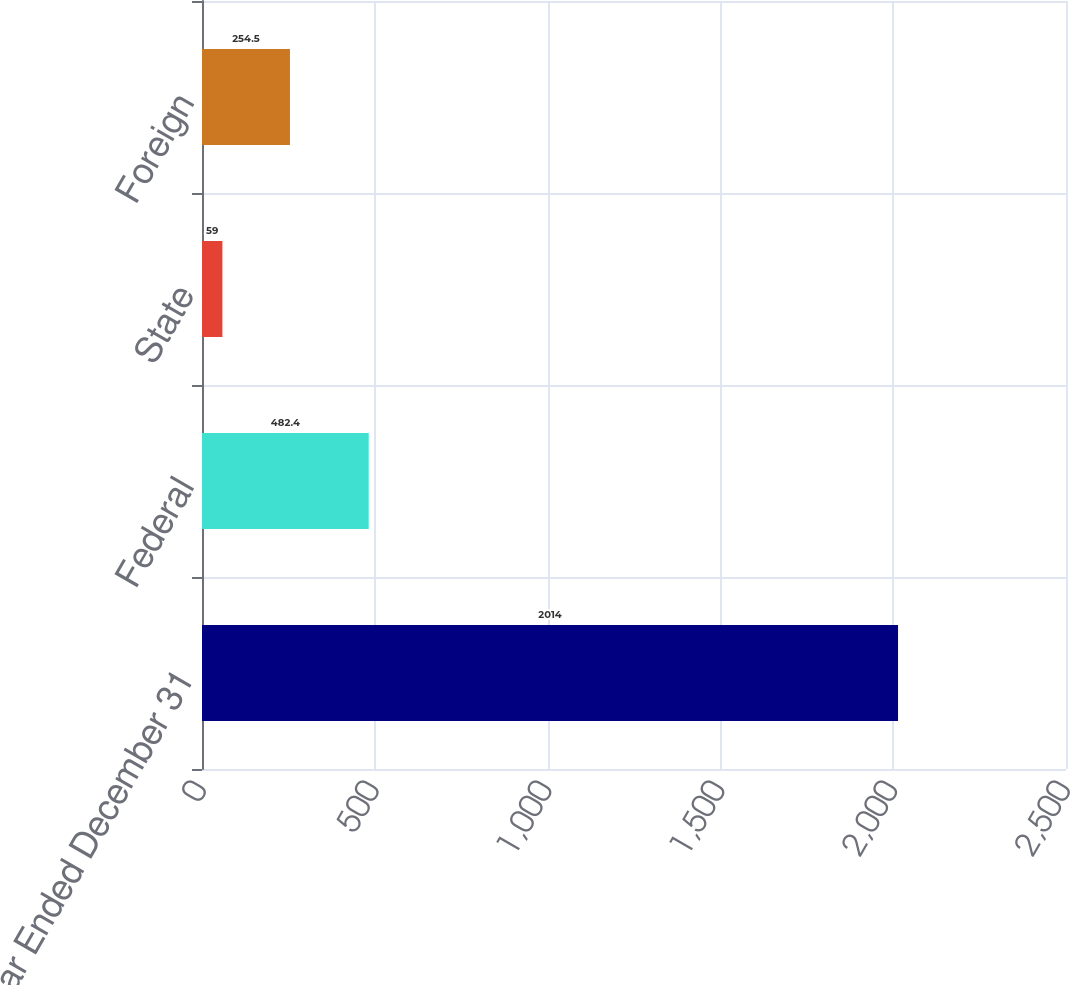Convert chart to OTSL. <chart><loc_0><loc_0><loc_500><loc_500><bar_chart><fcel>Year Ended December 31<fcel>Federal<fcel>State<fcel>Foreign<nl><fcel>2014<fcel>482.4<fcel>59<fcel>254.5<nl></chart> 